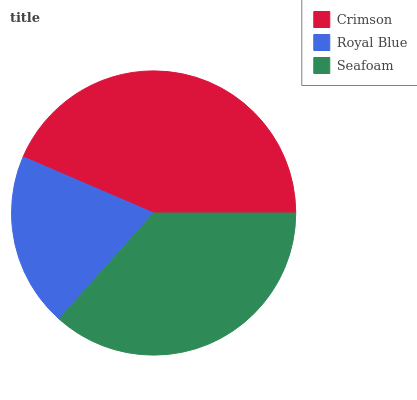Is Royal Blue the minimum?
Answer yes or no. Yes. Is Crimson the maximum?
Answer yes or no. Yes. Is Seafoam the minimum?
Answer yes or no. No. Is Seafoam the maximum?
Answer yes or no. No. Is Seafoam greater than Royal Blue?
Answer yes or no. Yes. Is Royal Blue less than Seafoam?
Answer yes or no. Yes. Is Royal Blue greater than Seafoam?
Answer yes or no. No. Is Seafoam less than Royal Blue?
Answer yes or no. No. Is Seafoam the high median?
Answer yes or no. Yes. Is Seafoam the low median?
Answer yes or no. Yes. Is Crimson the high median?
Answer yes or no. No. Is Crimson the low median?
Answer yes or no. No. 